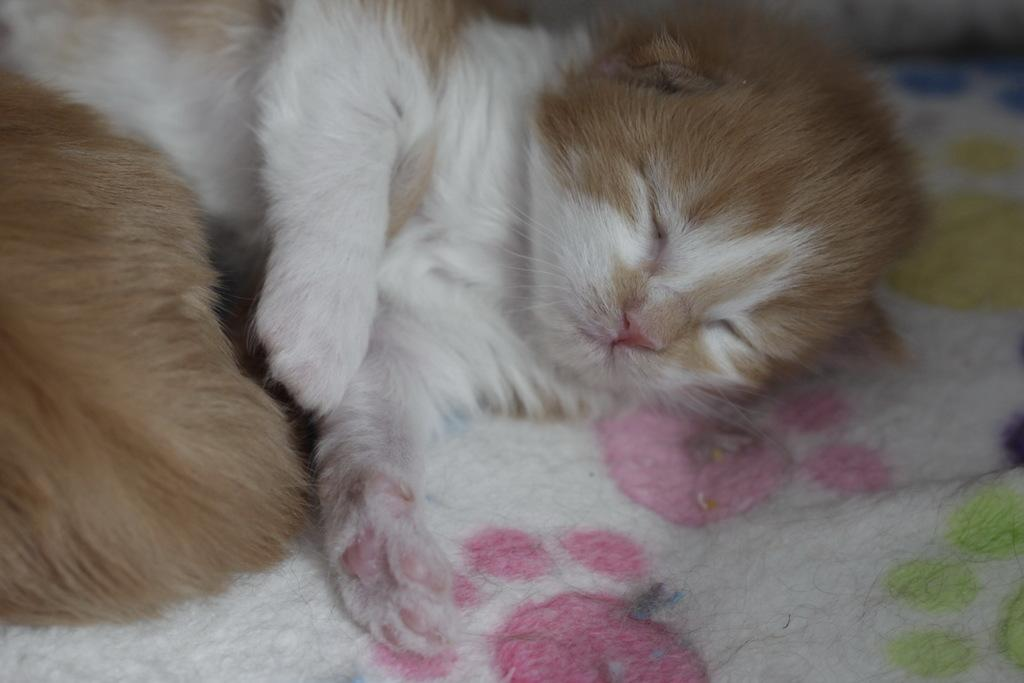What type of animal is in the image? There is a cat in the image. What is the cat doing in the image? The cat is sleeping in the image. On what surface is the cat resting? The cat is on a cloth in the image. What type of pig can be seen playing with an example in the image? There is no pig or example present in the image; it features a cat sleeping on a cloth. 